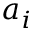<formula> <loc_0><loc_0><loc_500><loc_500>a _ { i }</formula> 